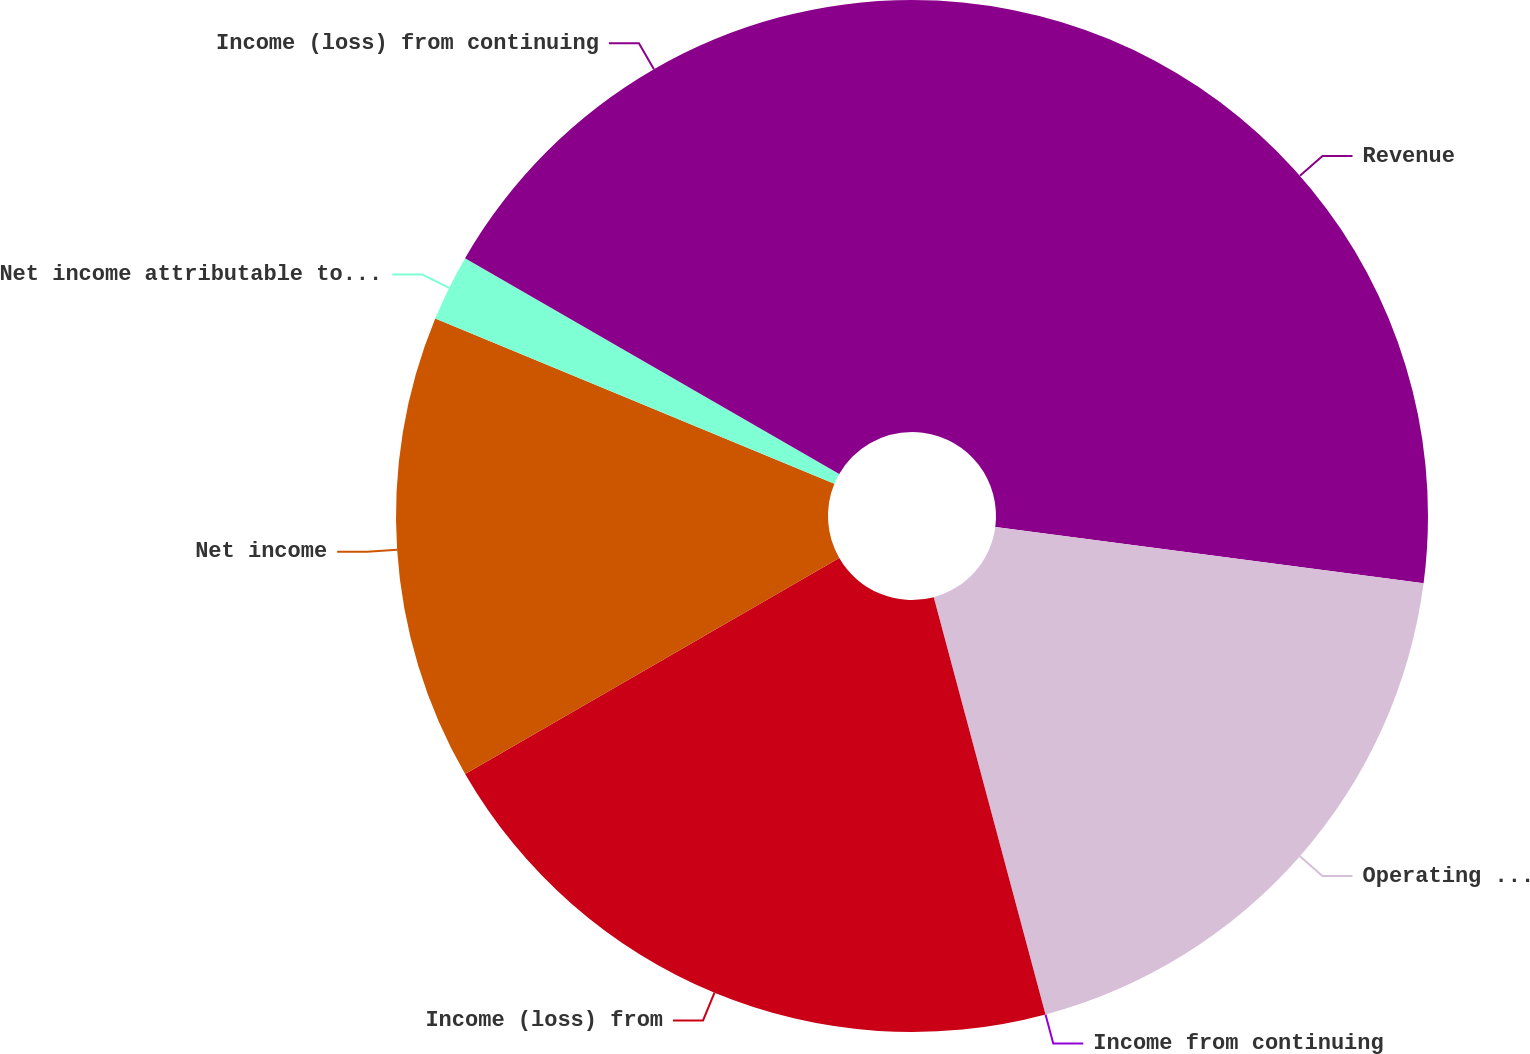<chart> <loc_0><loc_0><loc_500><loc_500><pie_chart><fcel>Revenue<fcel>Operating margin<fcel>Income from continuing<fcel>Income (loss) from<fcel>Net income<fcel>Net income attributable to The<fcel>Income (loss) from continuing<nl><fcel>27.08%<fcel>18.75%<fcel>0.0%<fcel>20.83%<fcel>14.58%<fcel>2.08%<fcel>16.67%<nl></chart> 